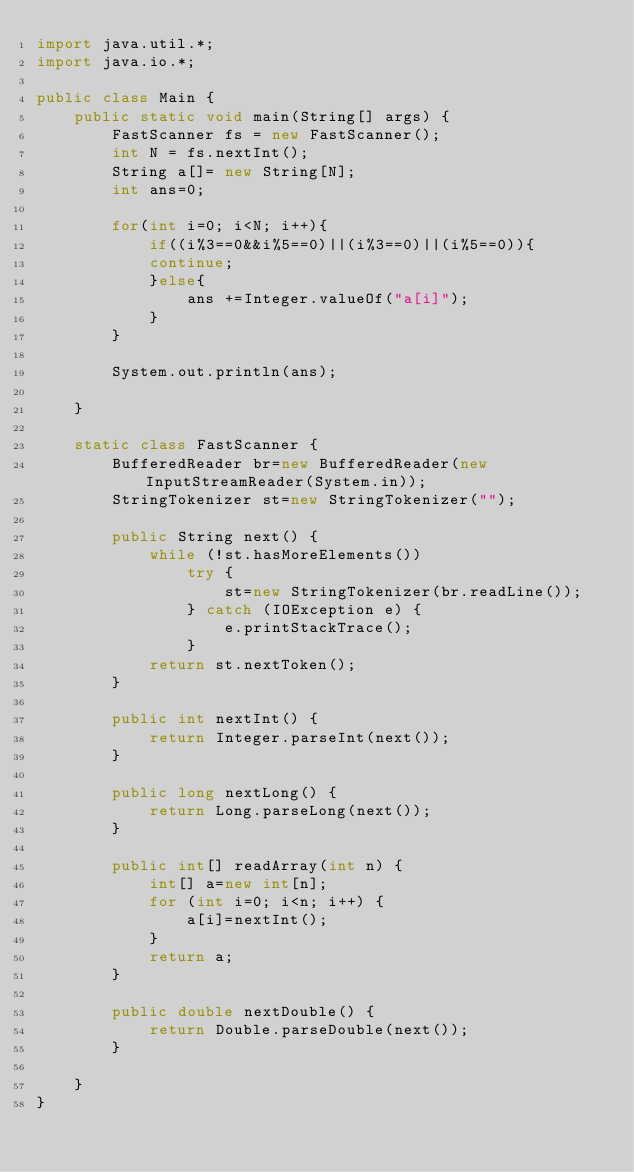Convert code to text. <code><loc_0><loc_0><loc_500><loc_500><_Java_>import java.util.*;
import java.io.*;

public class Main {	
	public static void main(String[] args) {
		FastScanner fs = new FastScanner();
		int N = fs.nextInt();
		String a[]= new String[N];
		int ans=0;
		
		for(int i=0; i<N; i++){
			if((i%3==0&&i%5==0)||(i%3==0)||(i%5==0)){
			continue;
			}else{
				ans +=Integer.valueOf("a[i]");
			}
		}
		
		System.out.println(ans);

	}

	static class FastScanner {
		BufferedReader br=new BufferedReader(new InputStreamReader(System.in));
		StringTokenizer st=new StringTokenizer("");

		public String next() {
			while (!st.hasMoreElements())
				try {
					st=new StringTokenizer(br.readLine());
				} catch (IOException e) {
					e.printStackTrace();
				}
			return st.nextToken();
		}

		public int nextInt() {
			return Integer.parseInt(next());
		}

		public long nextLong() {
			return Long.parseLong(next());
		}

		public int[] readArray(int n) {
			int[] a=new int[n];
			for (int i=0; i<n; i++) {
				a[i]=nextInt();
			}
			return a;
		}

		public double nextDouble() {
			return Double.parseDouble(next());
		}

	}
}
</code> 